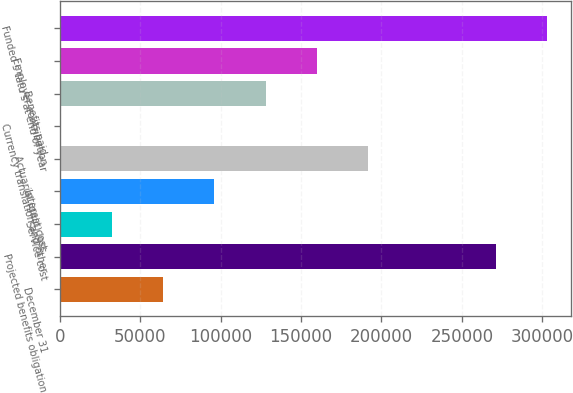Convert chart. <chart><loc_0><loc_0><loc_500><loc_500><bar_chart><fcel>December 31<fcel>Projected benefits obligation<fcel>Service cost<fcel>Interest cost<fcel>Actuarial (gain) loss<fcel>Currency translation and other<fcel>Benefits paid<fcel>Employer contribution<fcel>Funded s tatu s at end of year<nl><fcel>64507<fcel>270937<fcel>32768.5<fcel>96245.5<fcel>191461<fcel>1030<fcel>127984<fcel>159722<fcel>302676<nl></chart> 